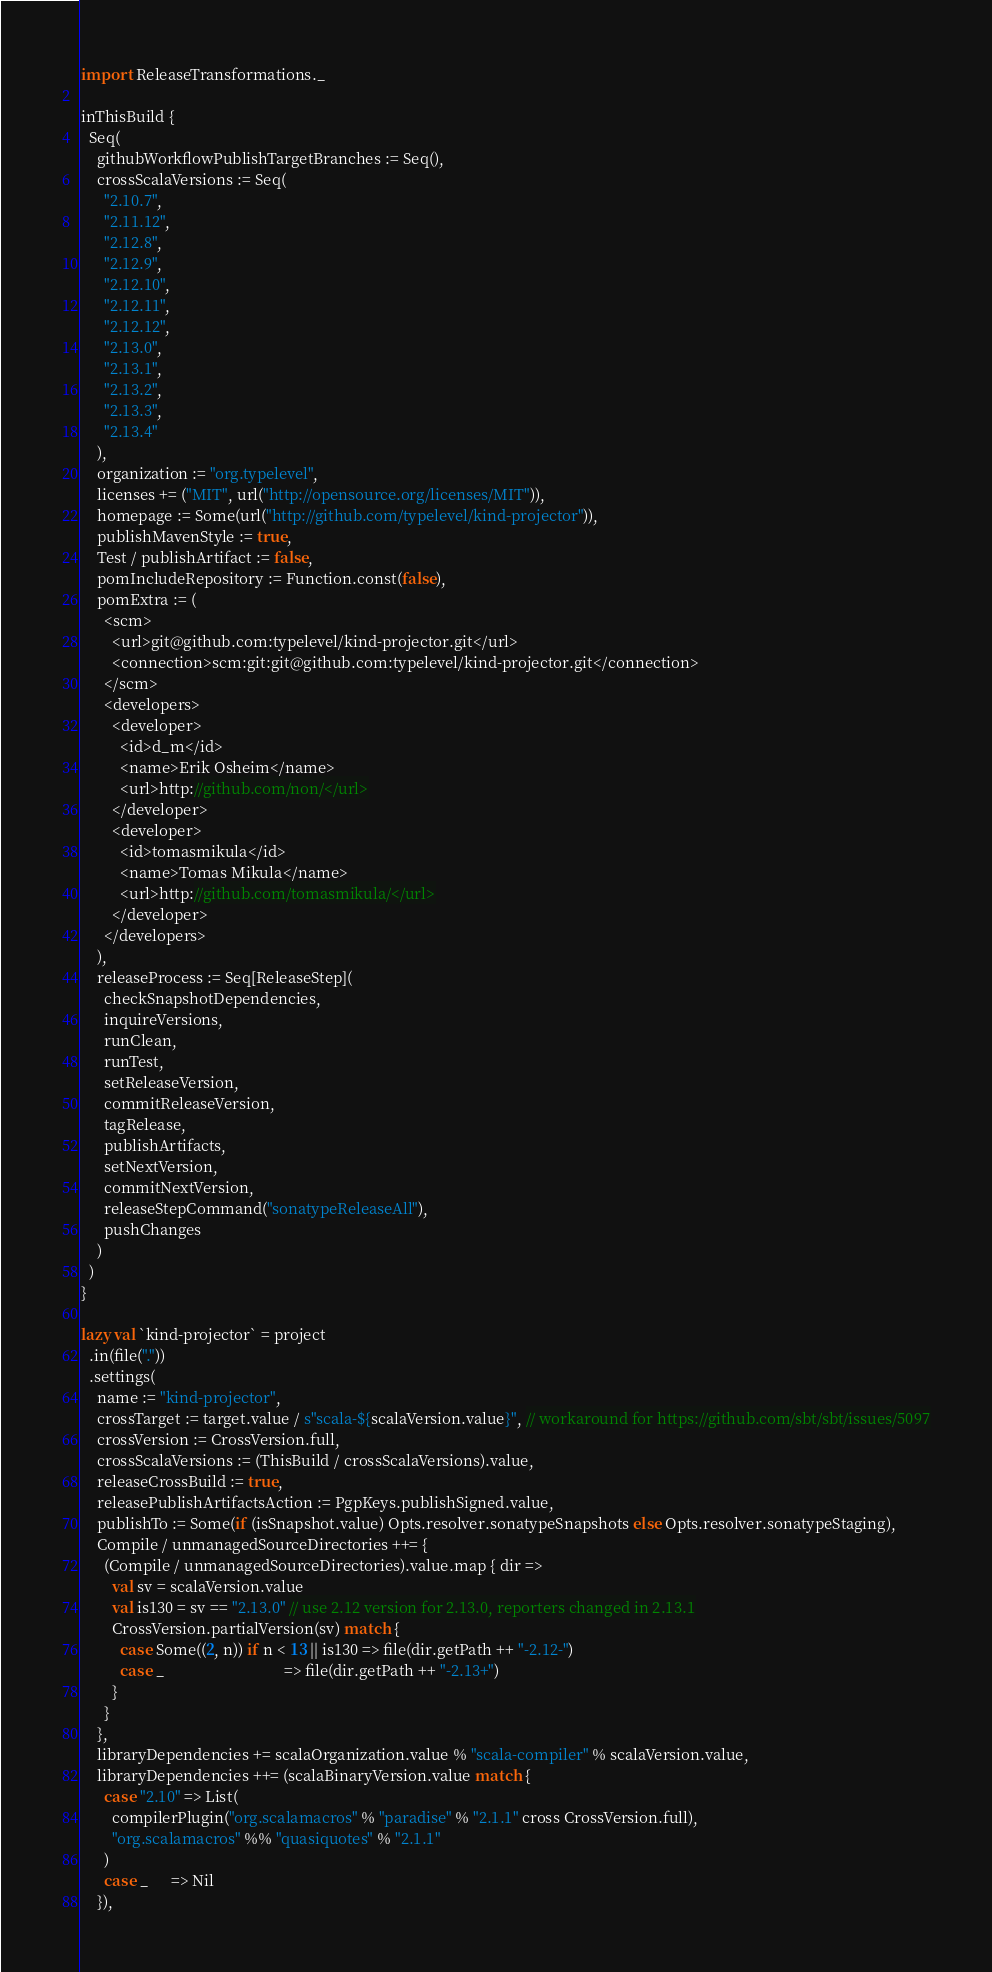<code> <loc_0><loc_0><loc_500><loc_500><_Scala_>import ReleaseTransformations._

inThisBuild {
  Seq(
    githubWorkflowPublishTargetBranches := Seq(),
    crossScalaVersions := Seq(
      "2.10.7",
      "2.11.12",
      "2.12.8",
      "2.12.9",
      "2.12.10",
      "2.12.11",
      "2.12.12",
      "2.13.0",
      "2.13.1",
      "2.13.2",
      "2.13.3",
      "2.13.4"
    ),
    organization := "org.typelevel",
    licenses += ("MIT", url("http://opensource.org/licenses/MIT")),
    homepage := Some(url("http://github.com/typelevel/kind-projector")),
    publishMavenStyle := true,
    Test / publishArtifact := false,
    pomIncludeRepository := Function.const(false),
    pomExtra := (
      <scm>
        <url>git@github.com:typelevel/kind-projector.git</url>
        <connection>scm:git:git@github.com:typelevel/kind-projector.git</connection>
      </scm>
      <developers>
        <developer>
          <id>d_m</id>
          <name>Erik Osheim</name>
          <url>http://github.com/non/</url>
        </developer>
        <developer>
          <id>tomasmikula</id>
          <name>Tomas Mikula</name>
          <url>http://github.com/tomasmikula/</url>
        </developer>
      </developers>
    ),
    releaseProcess := Seq[ReleaseStep](
      checkSnapshotDependencies,
      inquireVersions,
      runClean,
      runTest,
      setReleaseVersion,
      commitReleaseVersion,
      tagRelease,
      publishArtifacts,
      setNextVersion,
      commitNextVersion,
      releaseStepCommand("sonatypeReleaseAll"),
      pushChanges
    )
  )
}

lazy val `kind-projector` = project
  .in(file("."))
  .settings(
    name := "kind-projector",
    crossTarget := target.value / s"scala-${scalaVersion.value}", // workaround for https://github.com/sbt/sbt/issues/5097
    crossVersion := CrossVersion.full,
    crossScalaVersions := (ThisBuild / crossScalaVersions).value,
    releaseCrossBuild := true,
    releasePublishArtifactsAction := PgpKeys.publishSigned.value,
    publishTo := Some(if (isSnapshot.value) Opts.resolver.sonatypeSnapshots else Opts.resolver.sonatypeStaging),
    Compile / unmanagedSourceDirectories ++= {
      (Compile / unmanagedSourceDirectories).value.map { dir =>
        val sv = scalaVersion.value
        val is130 = sv == "2.13.0" // use 2.12 version for 2.13.0, reporters changed in 2.13.1
        CrossVersion.partialVersion(sv) match {
          case Some((2, n)) if n < 13 || is130 => file(dir.getPath ++ "-2.12-")
          case _                               => file(dir.getPath ++ "-2.13+")
        }
      }
    },
    libraryDependencies += scalaOrganization.value % "scala-compiler" % scalaVersion.value,
    libraryDependencies ++= (scalaBinaryVersion.value match {
      case "2.10" => List(
        compilerPlugin("org.scalamacros" % "paradise" % "2.1.1" cross CrossVersion.full),
        "org.scalamacros" %% "quasiquotes" % "2.1.1"
      )
      case _      => Nil
    }),</code> 